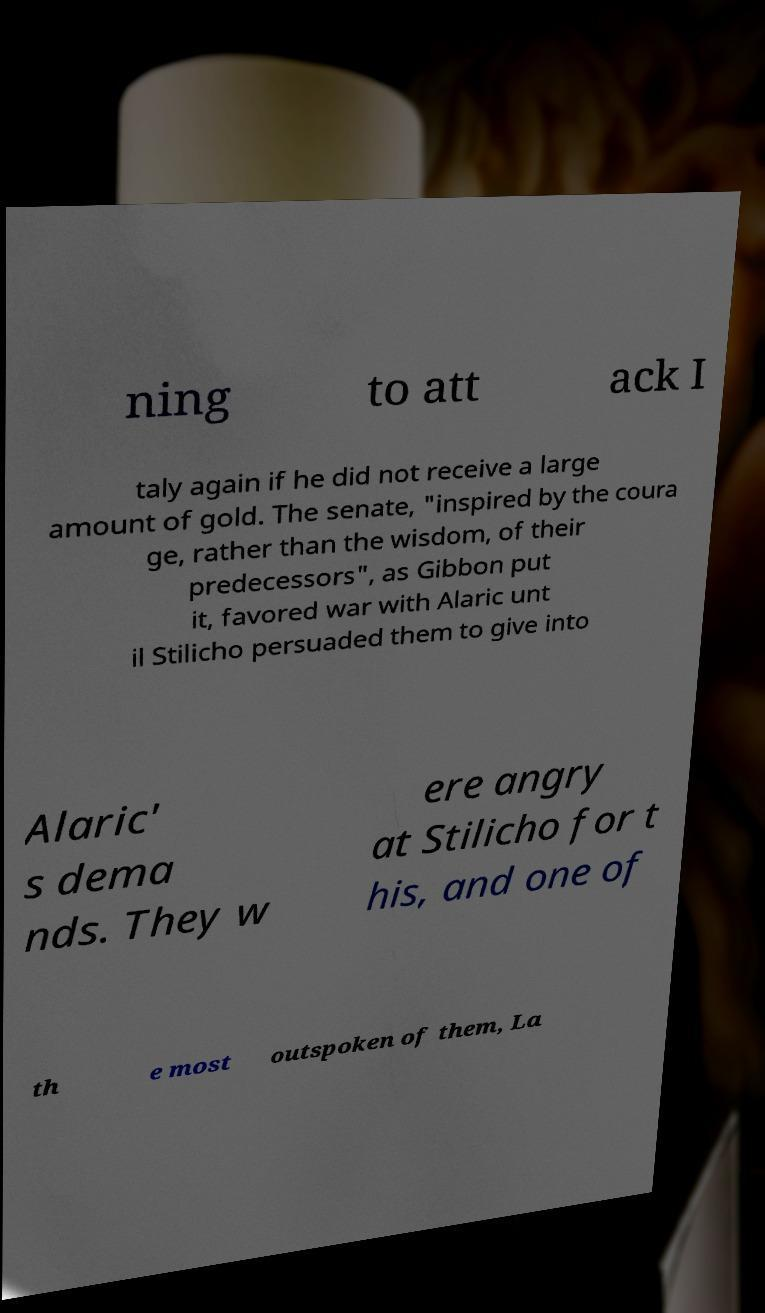I need the written content from this picture converted into text. Can you do that? ning to att ack I taly again if he did not receive a large amount of gold. The senate, "inspired by the coura ge, rather than the wisdom, of their predecessors", as Gibbon put it, favored war with Alaric unt il Stilicho persuaded them to give into Alaric' s dema nds. They w ere angry at Stilicho for t his, and one of th e most outspoken of them, La 